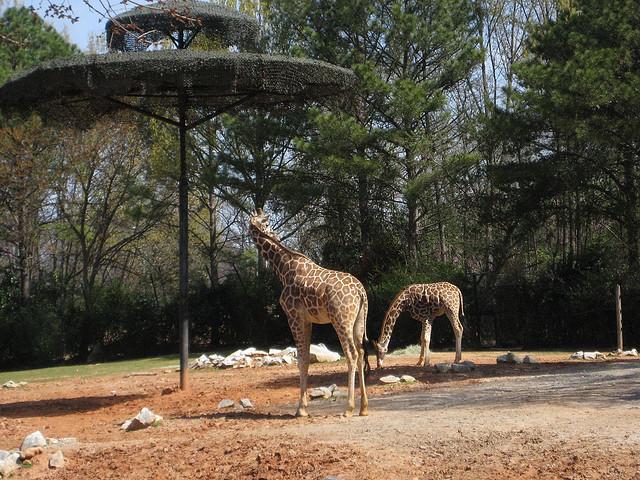What are the giraffes hanging out under?
Give a very brief answer. Canopy. Is it hot or cold in the picture?
Be succinct. Hot. Is this a game preserve?
Write a very short answer. Yes. How many giraffes are pictured?
Concise answer only. 2. 